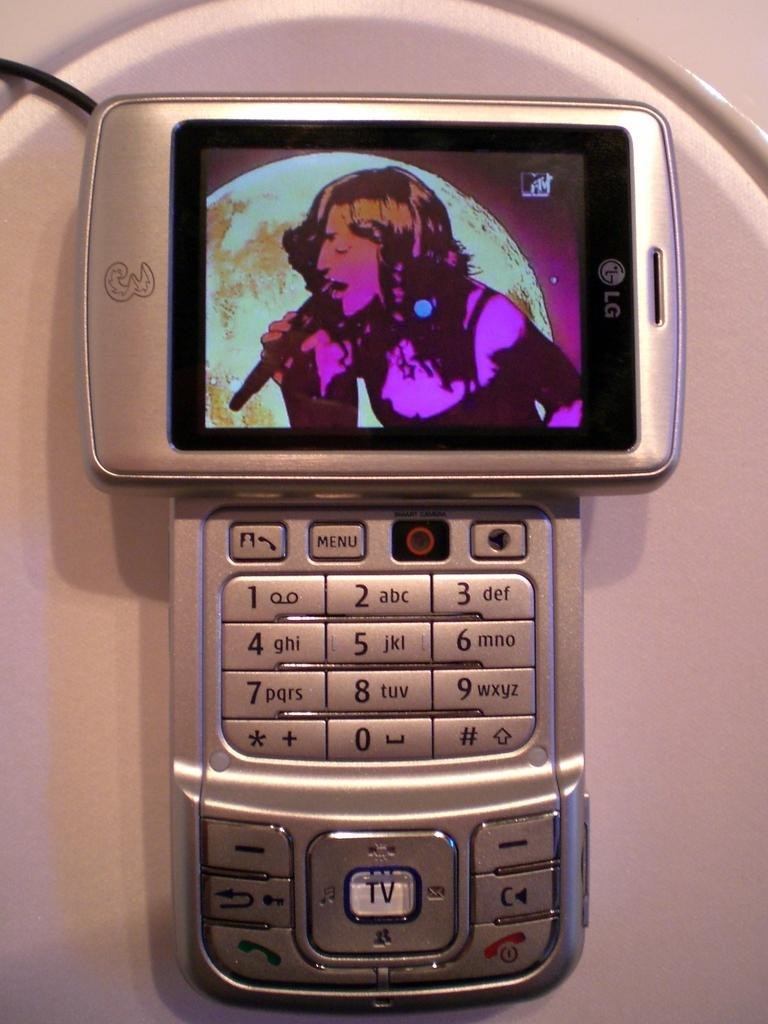<image>
Summarize the visual content of the image. The MTV channel is shown on an LG phone. 